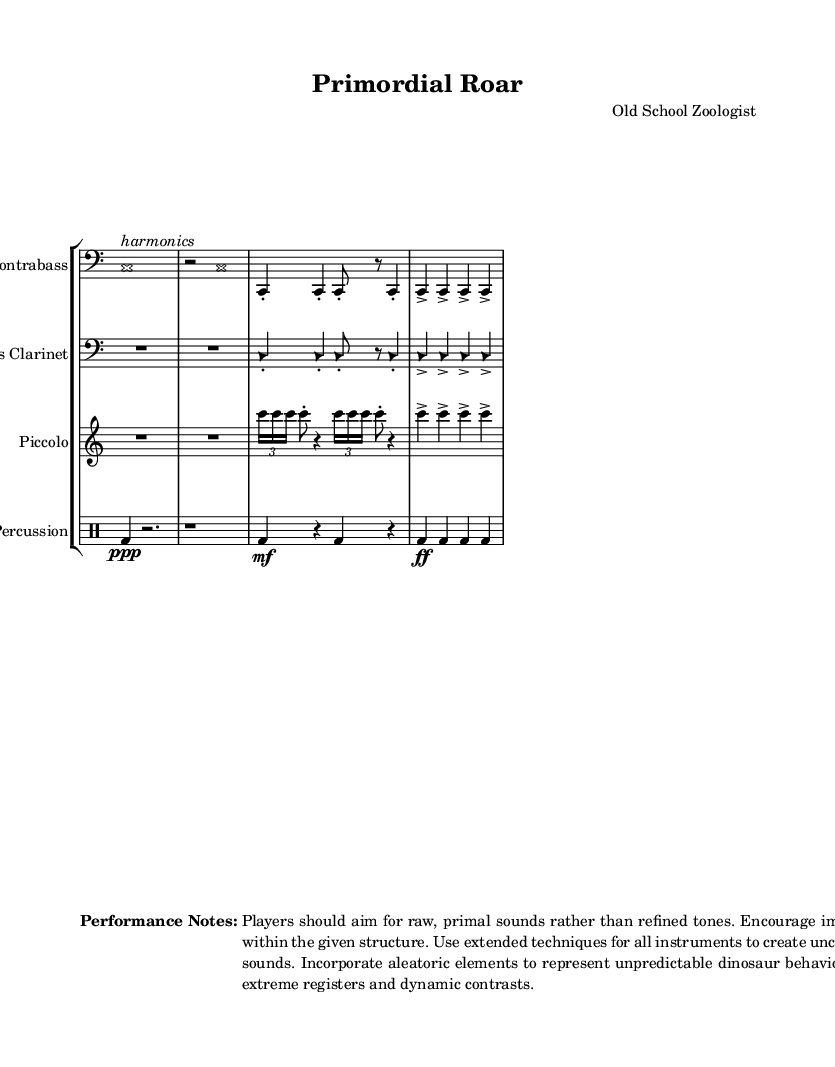What is the time signature of this piece? The time signature is specified as 4/4 at the beginning of the score, which indicates that there are four beats in each measure and the quarter note receives one beat.
Answer: 4/4 What instruments are featured in this composition? The score includes four instruments: Contrabass, Bass Clarinet, Piccolo, and Percussion. These are listed in the staff group at the beginning of the score as the instrument names.
Answer: Contrabass, Bass Clarinet, Piccolo, Percussion What is the dynamic marking for the bass drum in the percussion part? The first occurrence of the bass drum (bd) in the percussion part is marked as ppp (pianississimo), indicating it should be played very softly. This is noted directly in the drummode section.
Answer: ppp How many measures does the fourth instrument part have in the score? The fourth instrument, the percussion, consists of four measures as indicated by the notation and the structure of the drummode section.
Answer: 4 Which extended technique is mentioned for performance? The performance notes on the sheet music indicate the use of "extended techniques" for all instruments, which encourages players to explore unconventional sounds.
Answer: extended techniques What are players encouraged to focus on during the performance? The performance notes suggest that players should focus on "extreme registers and dynamic contrasts," which is important for producing the desired primal sound emulating dinosaur vocalizations.
Answer: extreme registers and dynamic contrasts 